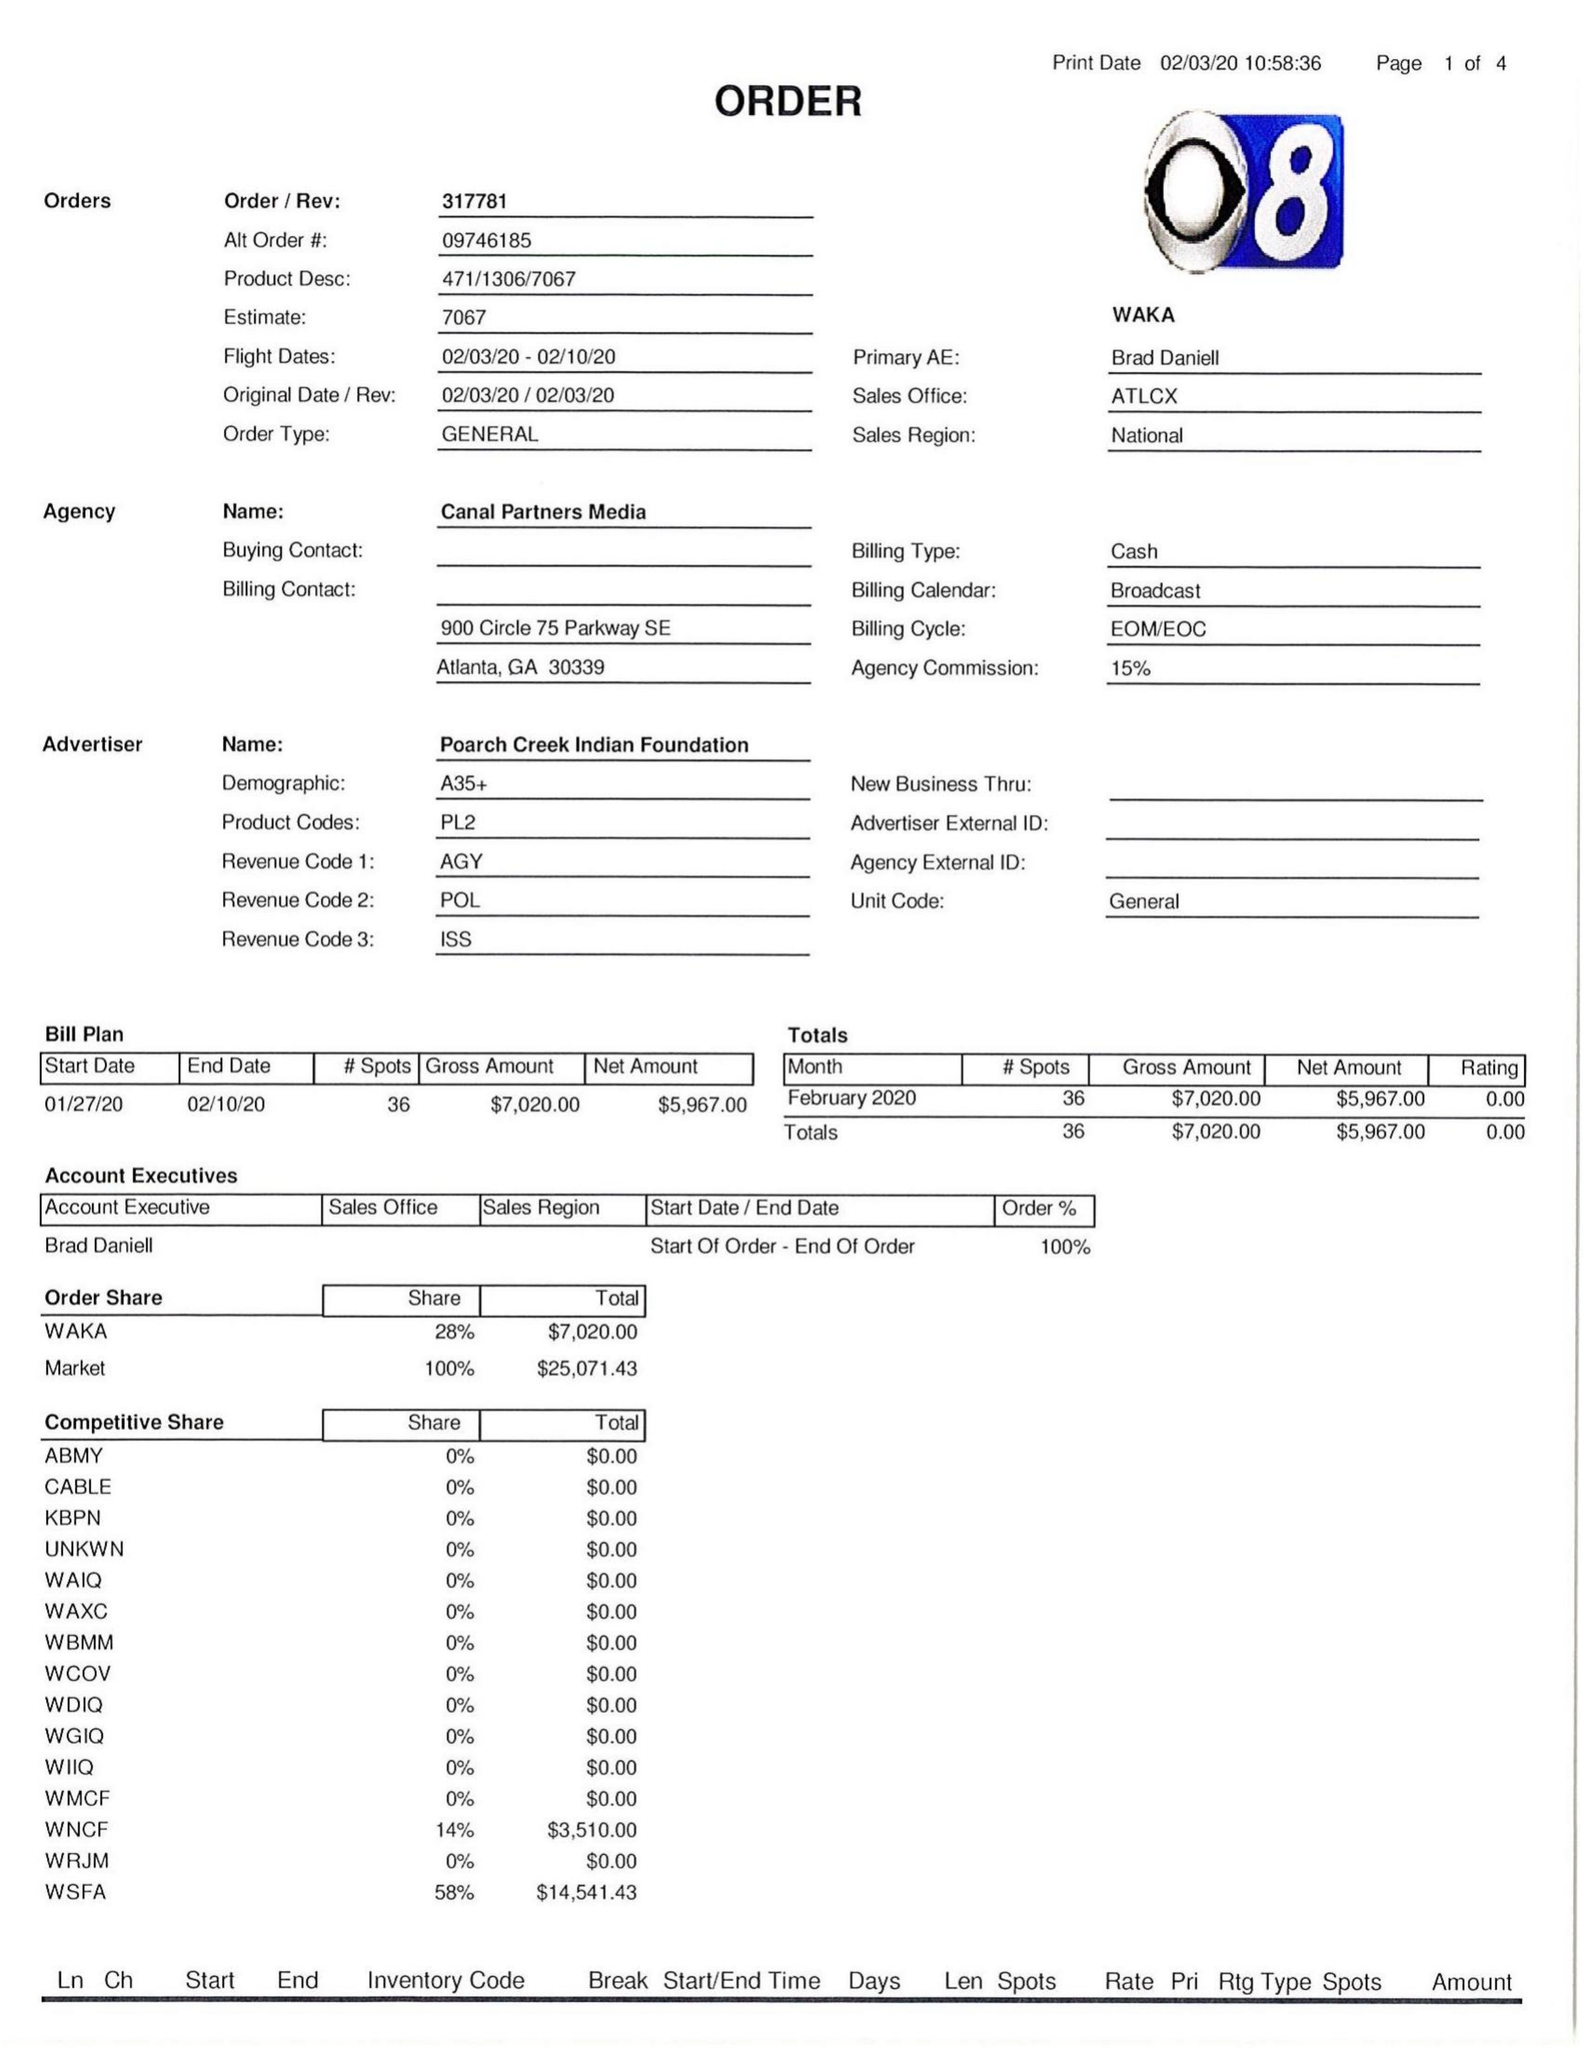What is the value for the contract_num?
Answer the question using a single word or phrase. 317781 